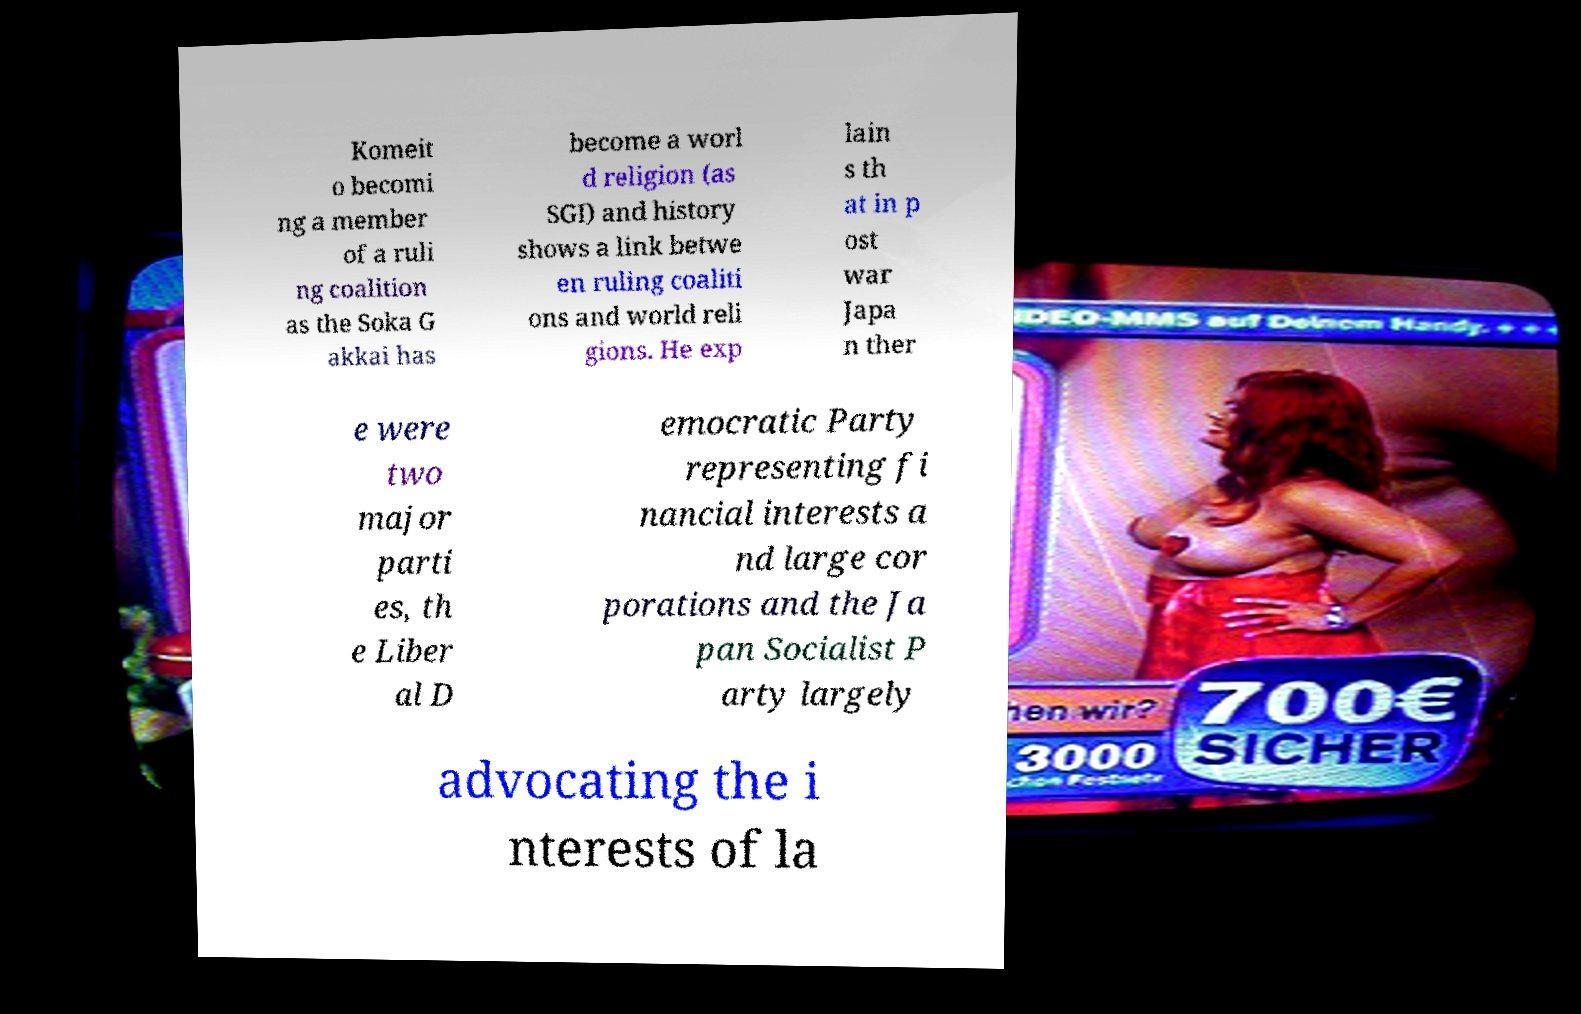Please read and relay the text visible in this image. What does it say? Komeit o becomi ng a member of a ruli ng coalition as the Soka G akkai has become a worl d religion (as SGI) and history shows a link betwe en ruling coaliti ons and world reli gions. He exp lain s th at in p ost war Japa n ther e were two major parti es, th e Liber al D emocratic Party representing fi nancial interests a nd large cor porations and the Ja pan Socialist P arty largely advocating the i nterests of la 